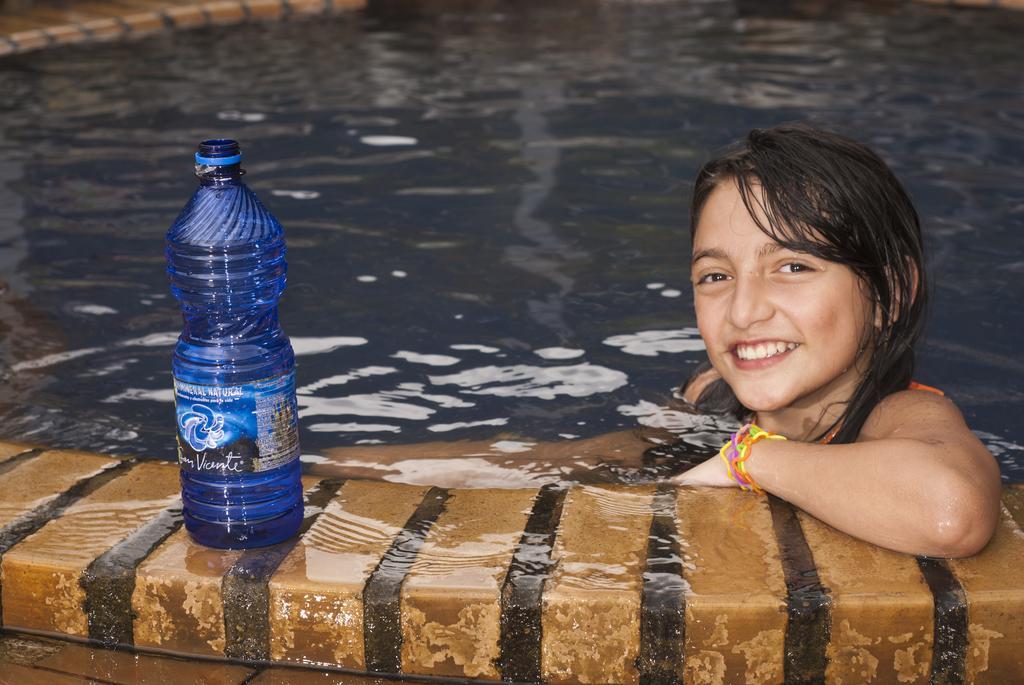Describe this image in one or two sentences. In this image I can see a girl is in a swimming pool. I can also see a smile on her face. Here I can see a water bottle. 